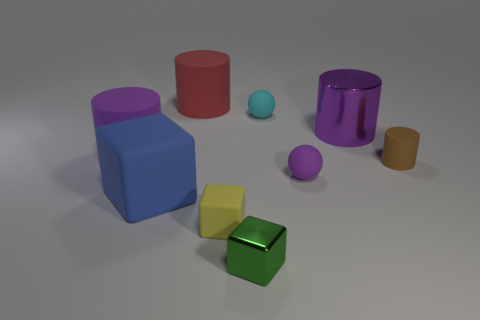How many large blue matte things are the same shape as the small metallic object?
Offer a very short reply. 1. What is the shape of the big purple object to the left of the purple matte sphere on the right side of the green shiny cube?
Provide a short and direct response. Cylinder. Does the purple cylinder left of the yellow thing have the same size as the metal block?
Give a very brief answer. No. There is a thing that is both right of the tiny metallic thing and left of the tiny purple matte ball; how big is it?
Give a very brief answer. Small. How many blocks have the same size as the brown rubber cylinder?
Provide a succinct answer. 2. How many tiny cyan matte spheres are on the left side of the purple object that is behind the big purple rubber cylinder?
Provide a succinct answer. 1. Does the big rubber object left of the large cube have the same color as the big metallic thing?
Your answer should be very brief. Yes. There is a tiny matte thing that is left of the small green metallic block that is to the right of the large blue thing; is there a small cyan matte object that is right of it?
Offer a terse response. Yes. What is the shape of the large object that is on the right side of the blue object and in front of the cyan matte object?
Provide a short and direct response. Cylinder. Are there any tiny rubber spheres that have the same color as the large metal cylinder?
Provide a short and direct response. Yes. 